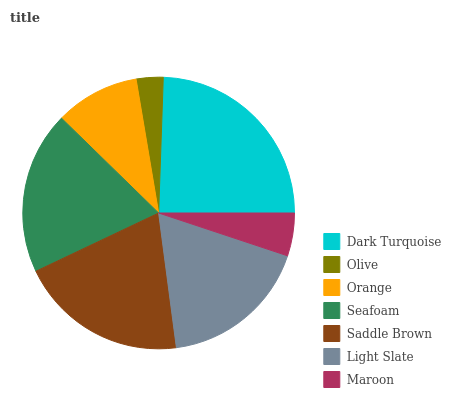Is Olive the minimum?
Answer yes or no. Yes. Is Dark Turquoise the maximum?
Answer yes or no. Yes. Is Orange the minimum?
Answer yes or no. No. Is Orange the maximum?
Answer yes or no. No. Is Orange greater than Olive?
Answer yes or no. Yes. Is Olive less than Orange?
Answer yes or no. Yes. Is Olive greater than Orange?
Answer yes or no. No. Is Orange less than Olive?
Answer yes or no. No. Is Light Slate the high median?
Answer yes or no. Yes. Is Light Slate the low median?
Answer yes or no. Yes. Is Dark Turquoise the high median?
Answer yes or no. No. Is Olive the low median?
Answer yes or no. No. 